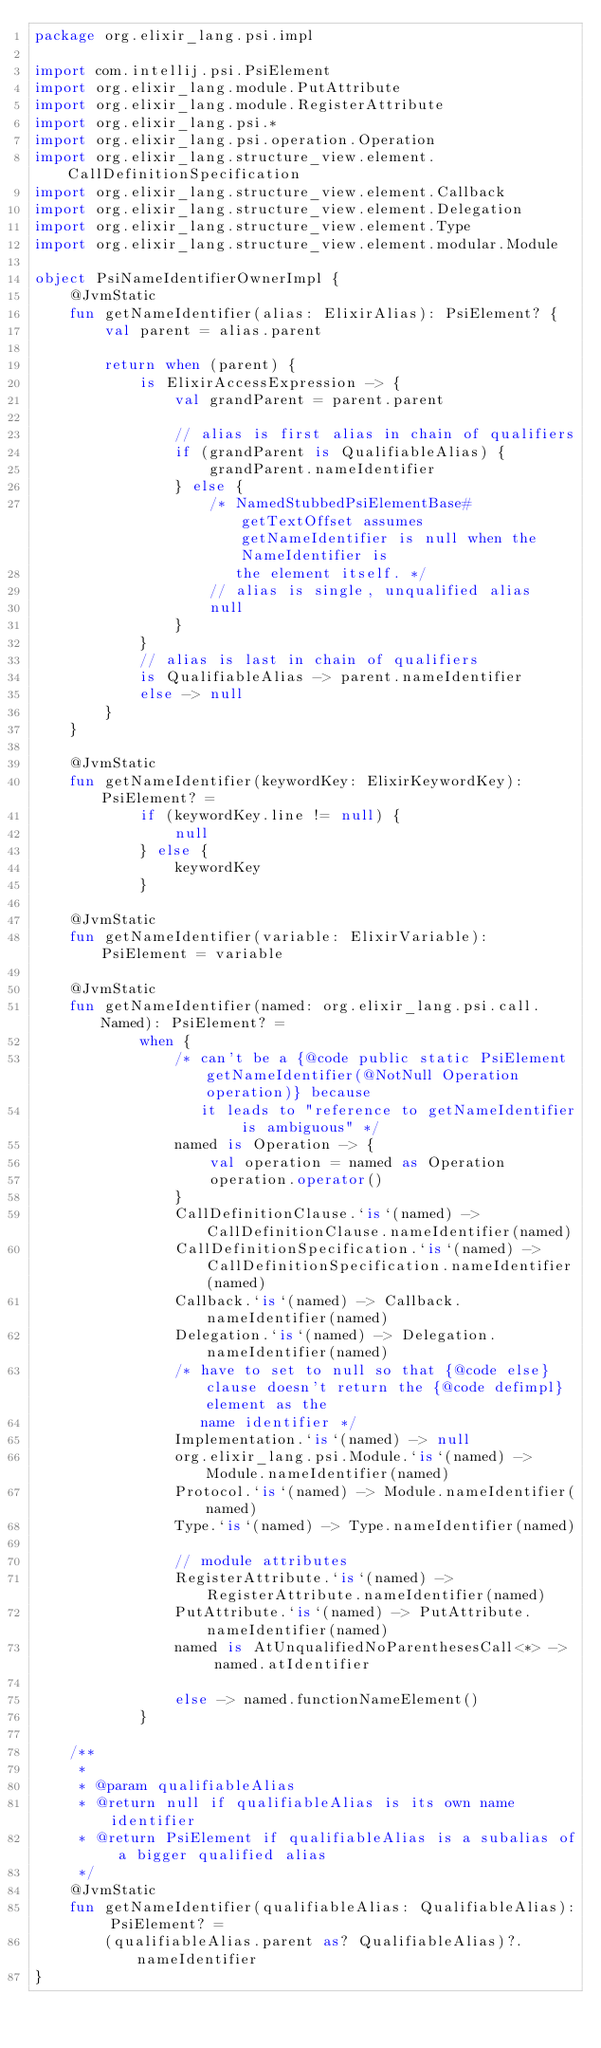<code> <loc_0><loc_0><loc_500><loc_500><_Kotlin_>package org.elixir_lang.psi.impl

import com.intellij.psi.PsiElement
import org.elixir_lang.module.PutAttribute
import org.elixir_lang.module.RegisterAttribute
import org.elixir_lang.psi.*
import org.elixir_lang.psi.operation.Operation
import org.elixir_lang.structure_view.element.CallDefinitionSpecification
import org.elixir_lang.structure_view.element.Callback
import org.elixir_lang.structure_view.element.Delegation
import org.elixir_lang.structure_view.element.Type
import org.elixir_lang.structure_view.element.modular.Module

object PsiNameIdentifierOwnerImpl {
    @JvmStatic
    fun getNameIdentifier(alias: ElixirAlias): PsiElement? {
        val parent = alias.parent

        return when (parent) {
            is ElixirAccessExpression -> {
                val grandParent = parent.parent

                // alias is first alias in chain of qualifiers
                if (grandParent is QualifiableAlias) {
                    grandParent.nameIdentifier
                } else {
                    /* NamedStubbedPsiElementBase#getTextOffset assumes getNameIdentifier is null when the NameIdentifier is
                       the element itself. */
                    // alias is single, unqualified alias
                    null
                }
            }
            // alias is last in chain of qualifiers
            is QualifiableAlias -> parent.nameIdentifier
            else -> null
        }
    }

    @JvmStatic
    fun getNameIdentifier(keywordKey: ElixirKeywordKey): PsiElement? =
            if (keywordKey.line != null) {
                null
            } else {
                keywordKey
            }

    @JvmStatic
    fun getNameIdentifier(variable: ElixirVariable): PsiElement = variable

    @JvmStatic
    fun getNameIdentifier(named: org.elixir_lang.psi.call.Named): PsiElement? =
            when {
                /* can't be a {@code public static PsiElement getNameIdentifier(@NotNull Operation operation)} because
                   it leads to "reference to getNameIdentifier is ambiguous" */
                named is Operation -> {
                    val operation = named as Operation
                    operation.operator()
                }
                CallDefinitionClause.`is`(named) -> CallDefinitionClause.nameIdentifier(named)
                CallDefinitionSpecification.`is`(named) -> CallDefinitionSpecification.nameIdentifier(named)
                Callback.`is`(named) -> Callback.nameIdentifier(named)
                Delegation.`is`(named) -> Delegation.nameIdentifier(named)
                /* have to set to null so that {@code else} clause doesn't return the {@code defimpl} element as the
                   name identifier */
                Implementation.`is`(named) -> null
                org.elixir_lang.psi.Module.`is`(named) -> Module.nameIdentifier(named)
                Protocol.`is`(named) -> Module.nameIdentifier(named)
                Type.`is`(named) -> Type.nameIdentifier(named)

                // module attributes
                RegisterAttribute.`is`(named) -> RegisterAttribute.nameIdentifier(named)
                PutAttribute.`is`(named) -> PutAttribute.nameIdentifier(named)
                named is AtUnqualifiedNoParenthesesCall<*> ->  named.atIdentifier

                else -> named.functionNameElement()
            }

    /**
     *
     * @param qualifiableAlias
     * @return null if qualifiableAlias is its own name identifier
     * @return PsiElement if qualifiableAlias is a subalias of a bigger qualified alias
     */
    @JvmStatic
    fun getNameIdentifier(qualifiableAlias: QualifiableAlias): PsiElement? =
        (qualifiableAlias.parent as? QualifiableAlias)?.nameIdentifier
}
</code> 